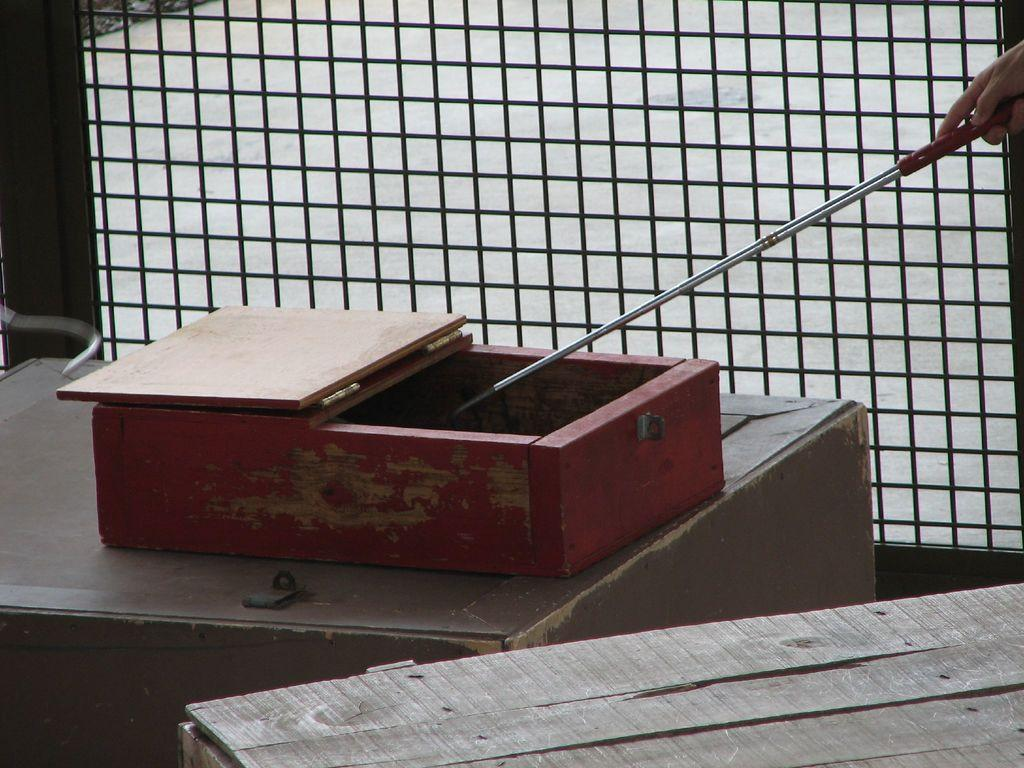What object can be seen in the image? There is a box in the image. Can you describe any other elements in the image? The hand of a person is visible in the image. How many ladybugs can be seen on the box in the image? There are no ladybugs visible on the box in the image. What type of kitty is sitting on top of the box in the image? There is no kitty present on top of the box in the image. 